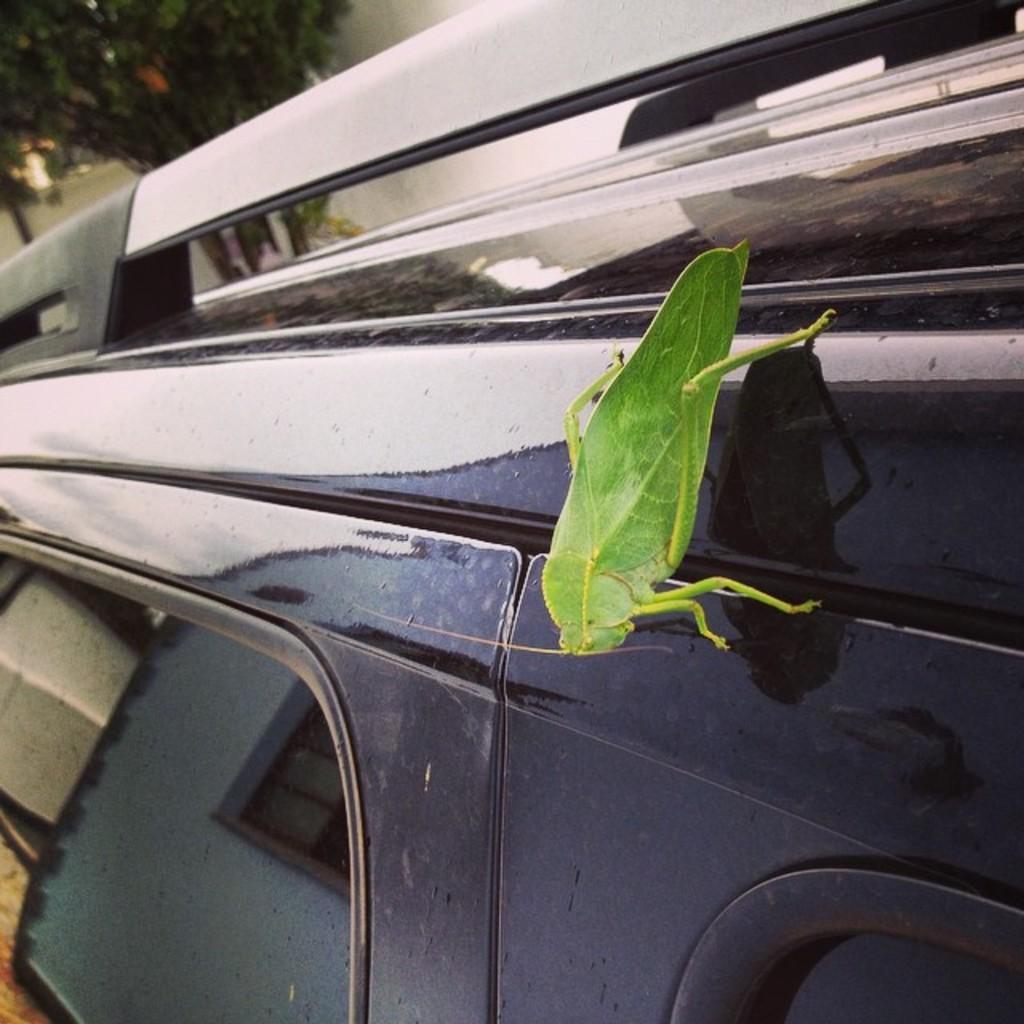How would you summarize this image in a sentence or two? There is one insect on a vehicle as we can see in the middle of this image. We can see a tree in the top left corner of this image. 